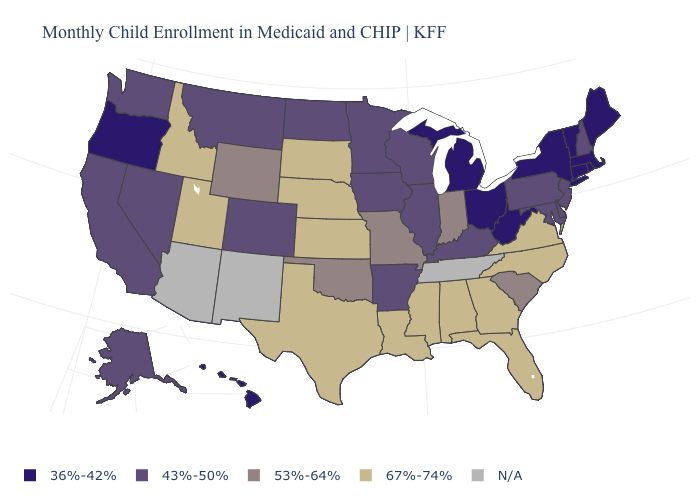What is the highest value in the West ?
Keep it brief. 67%-74%. What is the value of Montana?
Write a very short answer. 43%-50%. Does the first symbol in the legend represent the smallest category?
Be succinct. Yes. What is the lowest value in states that border Virginia?
Concise answer only. 36%-42%. Name the states that have a value in the range 36%-42%?
Be succinct. Connecticut, Hawaii, Maine, Massachusetts, Michigan, New York, Ohio, Oregon, Rhode Island, Vermont, West Virginia. What is the value of North Dakota?
Write a very short answer. 43%-50%. What is the value of Alabama?
Answer briefly. 67%-74%. Among the states that border California , which have the highest value?
Answer briefly. Nevada. What is the value of Indiana?
Quick response, please. 53%-64%. Does the map have missing data?
Keep it brief. Yes. What is the value of Wisconsin?
Concise answer only. 43%-50%. Does Kentucky have the highest value in the USA?
Quick response, please. No. Among the states that border Kansas , does Missouri have the lowest value?
Be succinct. No. Among the states that border Vermont , which have the highest value?
Be succinct. New Hampshire. 